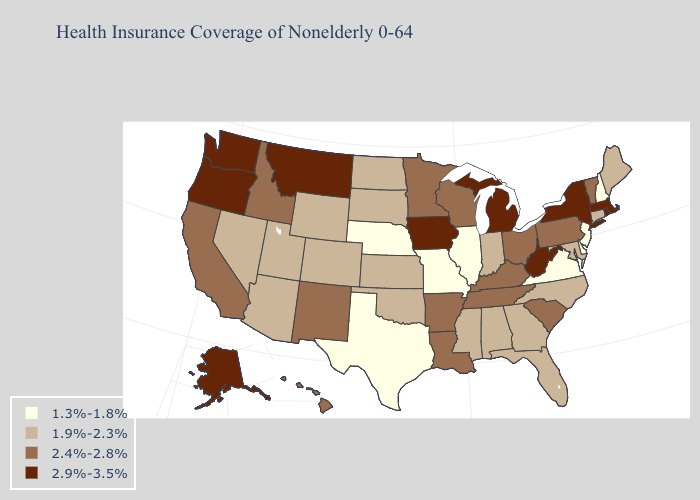What is the highest value in the USA?
Short answer required. 2.9%-3.5%. Name the states that have a value in the range 1.9%-2.3%?
Write a very short answer. Alabama, Arizona, Colorado, Connecticut, Florida, Georgia, Indiana, Kansas, Maine, Maryland, Mississippi, Nevada, North Carolina, North Dakota, Oklahoma, South Dakota, Utah, Wyoming. Does Idaho have the highest value in the USA?
Short answer required. No. Which states have the lowest value in the South?
Give a very brief answer. Delaware, Texas, Virginia. What is the value of Kentucky?
Concise answer only. 2.4%-2.8%. Does Maryland have a lower value than Illinois?
Short answer required. No. What is the value of Ohio?
Quick response, please. 2.4%-2.8%. Name the states that have a value in the range 1.9%-2.3%?
Concise answer only. Alabama, Arizona, Colorado, Connecticut, Florida, Georgia, Indiana, Kansas, Maine, Maryland, Mississippi, Nevada, North Carolina, North Dakota, Oklahoma, South Dakota, Utah, Wyoming. Does Maryland have the same value as Arizona?
Write a very short answer. Yes. Is the legend a continuous bar?
Answer briefly. No. What is the value of Montana?
Concise answer only. 2.9%-3.5%. What is the lowest value in states that border Virginia?
Give a very brief answer. 1.9%-2.3%. What is the lowest value in the Northeast?
Write a very short answer. 1.3%-1.8%. Name the states that have a value in the range 1.3%-1.8%?
Short answer required. Delaware, Illinois, Missouri, Nebraska, New Hampshire, New Jersey, Texas, Virginia. What is the highest value in the MidWest ?
Write a very short answer. 2.9%-3.5%. 